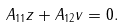Convert formula to latex. <formula><loc_0><loc_0><loc_500><loc_500>A _ { 1 1 } z + A _ { 1 2 } v = 0 .</formula> 